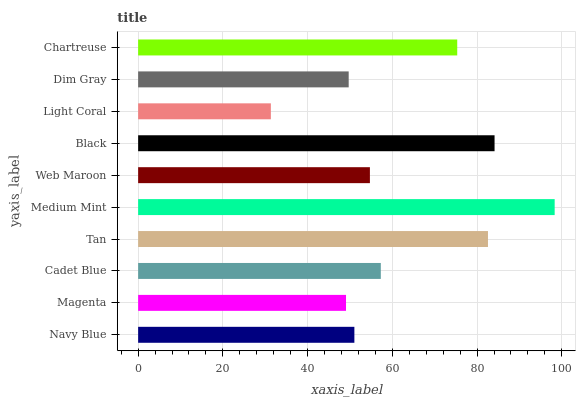Is Light Coral the minimum?
Answer yes or no. Yes. Is Medium Mint the maximum?
Answer yes or no. Yes. Is Magenta the minimum?
Answer yes or no. No. Is Magenta the maximum?
Answer yes or no. No. Is Navy Blue greater than Magenta?
Answer yes or no. Yes. Is Magenta less than Navy Blue?
Answer yes or no. Yes. Is Magenta greater than Navy Blue?
Answer yes or no. No. Is Navy Blue less than Magenta?
Answer yes or no. No. Is Cadet Blue the high median?
Answer yes or no. Yes. Is Web Maroon the low median?
Answer yes or no. Yes. Is Dim Gray the high median?
Answer yes or no. No. Is Black the low median?
Answer yes or no. No. 